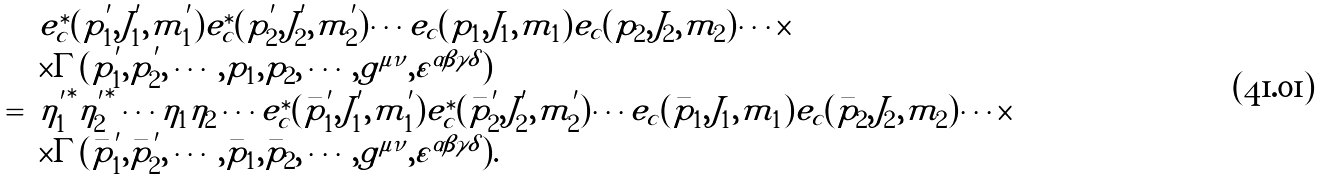Convert formula to latex. <formula><loc_0><loc_0><loc_500><loc_500>\begin{array} { r l } & e ^ { \ast } _ { c } ( p _ { 1 } ^ { ^ { \prime } } , J _ { 1 } ^ { ^ { \prime } } , m _ { 1 } ^ { ^ { \prime } } ) e ^ { \ast } _ { c } ( p _ { 2 } ^ { ^ { \prime } } , J _ { 2 } ^ { ^ { \prime } } , m _ { 2 } ^ { ^ { \prime } } ) \cdots e _ { c } ( p _ { 1 } , J _ { 1 } , m _ { 1 } ) e _ { c } ( p _ { 2 } , J _ { 2 } , m _ { 2 } ) \cdots \times \\ & \times \Gamma ( p _ { 1 } ^ { ^ { \prime } } , p _ { 2 } ^ { ^ { \prime } } , \cdots , p _ { 1 } , p _ { 2 } , \cdots , g ^ { \mu \nu } , \varepsilon ^ { \alpha \beta \gamma \delta } ) \\ = & { \eta _ { 1 } ^ { ^ { \prime } } } ^ { \ast } { \eta _ { 2 } ^ { ^ { \prime } } } ^ { \ast } \cdots \eta _ { 1 } \eta _ { 2 } \cdots e ^ { \ast } _ { c } ( \bar { p } _ { 1 } ^ { ^ { \prime } } , J _ { 1 } ^ { ^ { \prime } } , m _ { 1 } ^ { ^ { \prime } } ) e ^ { \ast } _ { c } ( \bar { p } _ { 2 } ^ { ^ { \prime } } , J _ { 2 } ^ { ^ { \prime } } , m _ { 2 } ^ { ^ { \prime } } ) \cdots e _ { c } ( \bar { p } _ { 1 } , J _ { 1 } , m _ { 1 } ) e _ { c } ( \bar { p } _ { 2 } , J _ { 2 } , m _ { 2 } ) \cdots \times \\ & \times \Gamma ( \bar { p } _ { 1 } ^ { ^ { \prime } } , \bar { p } _ { 2 } ^ { ^ { \prime } } , \cdots , \bar { p } _ { 1 } , \bar { p } _ { 2 } , \cdots , g ^ { \mu \nu } , \varepsilon ^ { \alpha \beta \gamma \delta } ) . \end{array}</formula> 